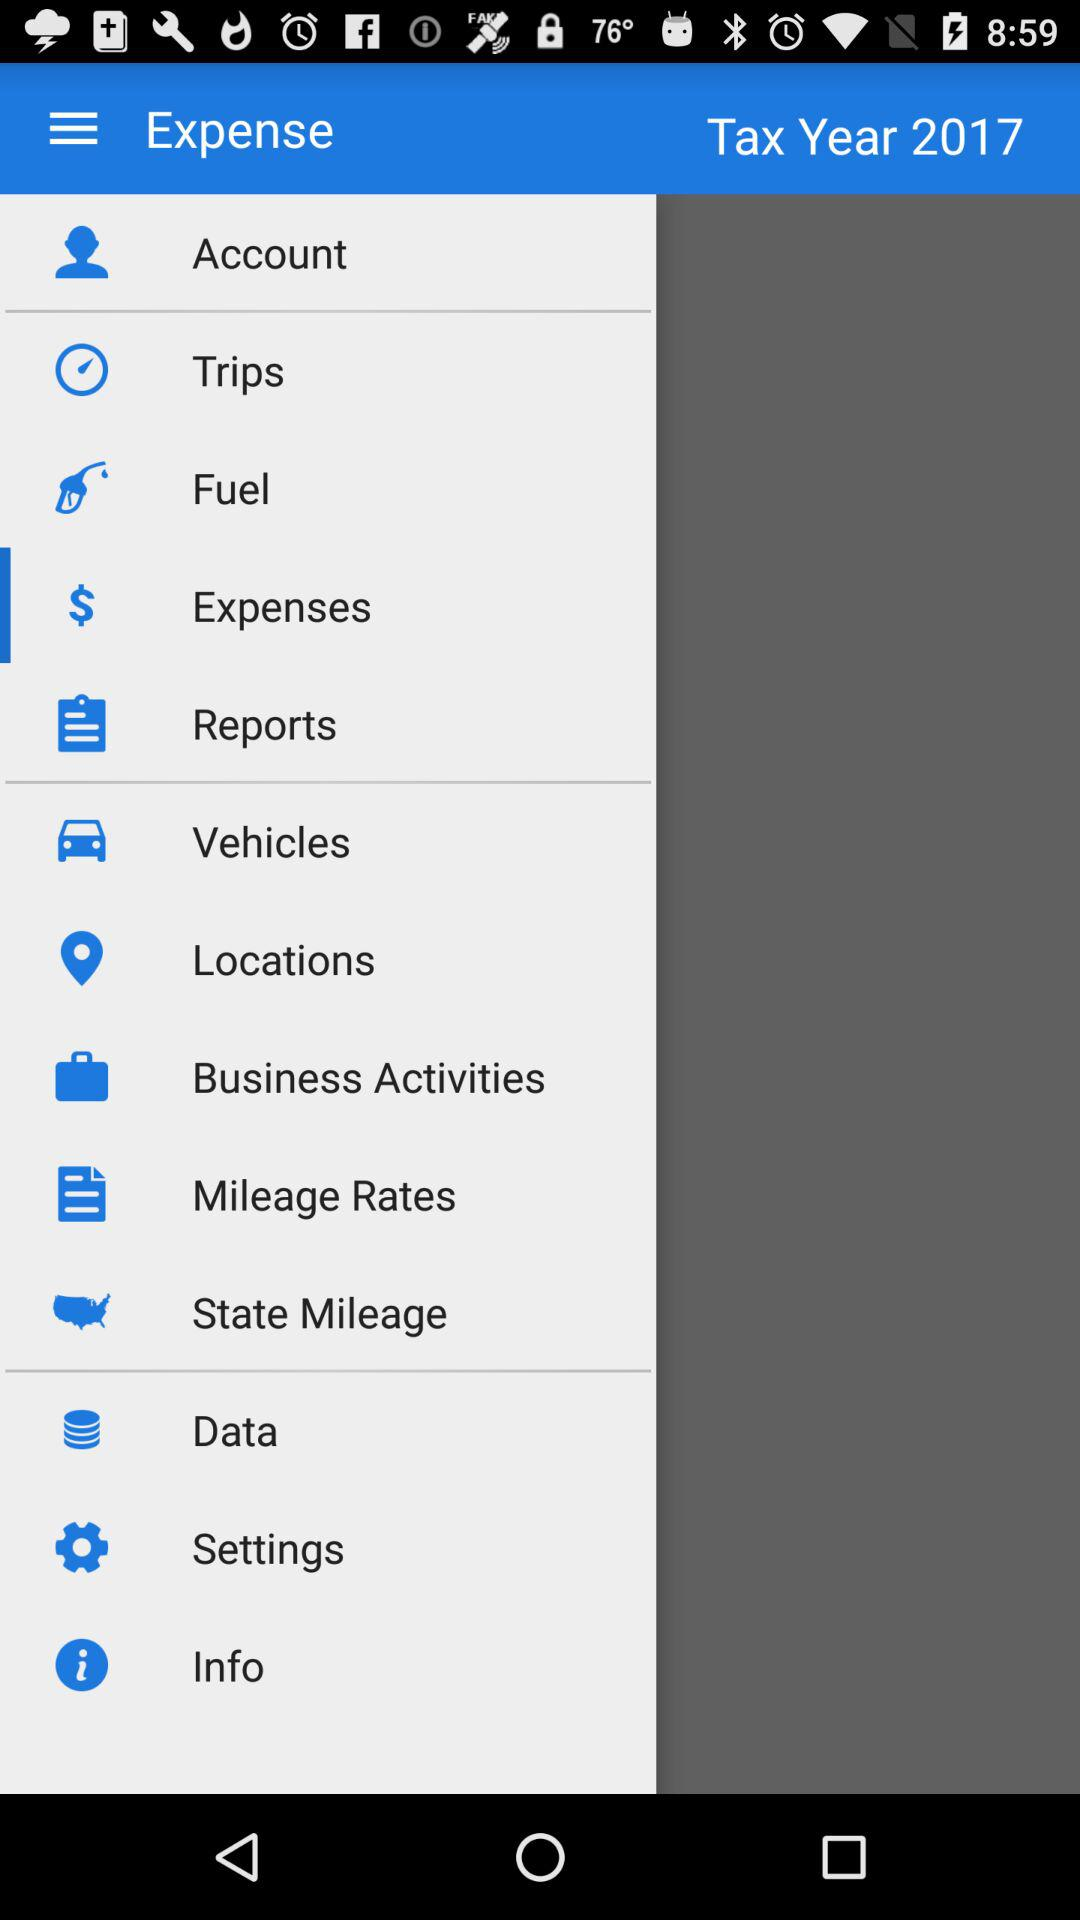What is the tax year? The tax year is 2017. 